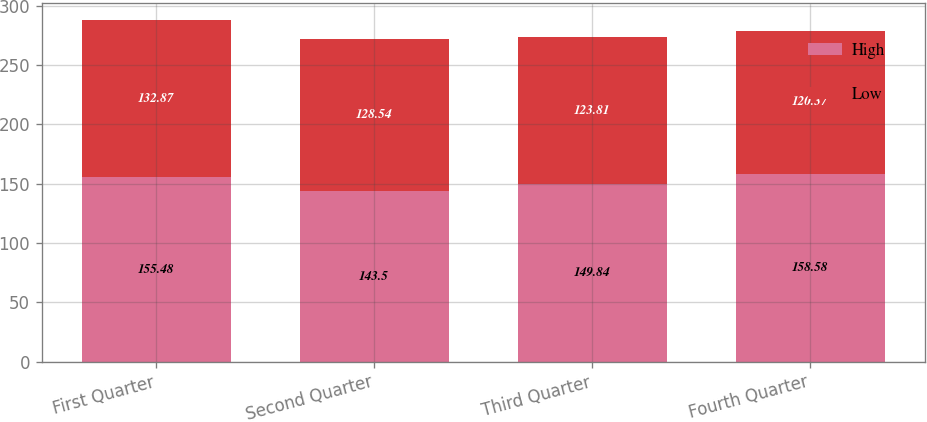Convert chart. <chart><loc_0><loc_0><loc_500><loc_500><stacked_bar_chart><ecel><fcel>First Quarter<fcel>Second Quarter<fcel>Third Quarter<fcel>Fourth Quarter<nl><fcel>High<fcel>155.48<fcel>143.5<fcel>149.84<fcel>158.58<nl><fcel>Low<fcel>132.87<fcel>128.54<fcel>123.81<fcel>120.37<nl></chart> 